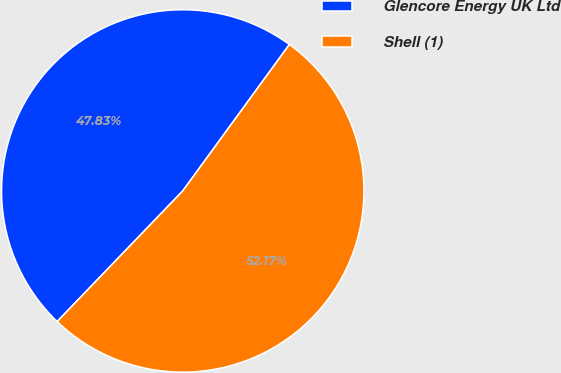Convert chart. <chart><loc_0><loc_0><loc_500><loc_500><pie_chart><fcel>Glencore Energy UK Ltd<fcel>Shell (1)<nl><fcel>47.83%<fcel>52.17%<nl></chart> 